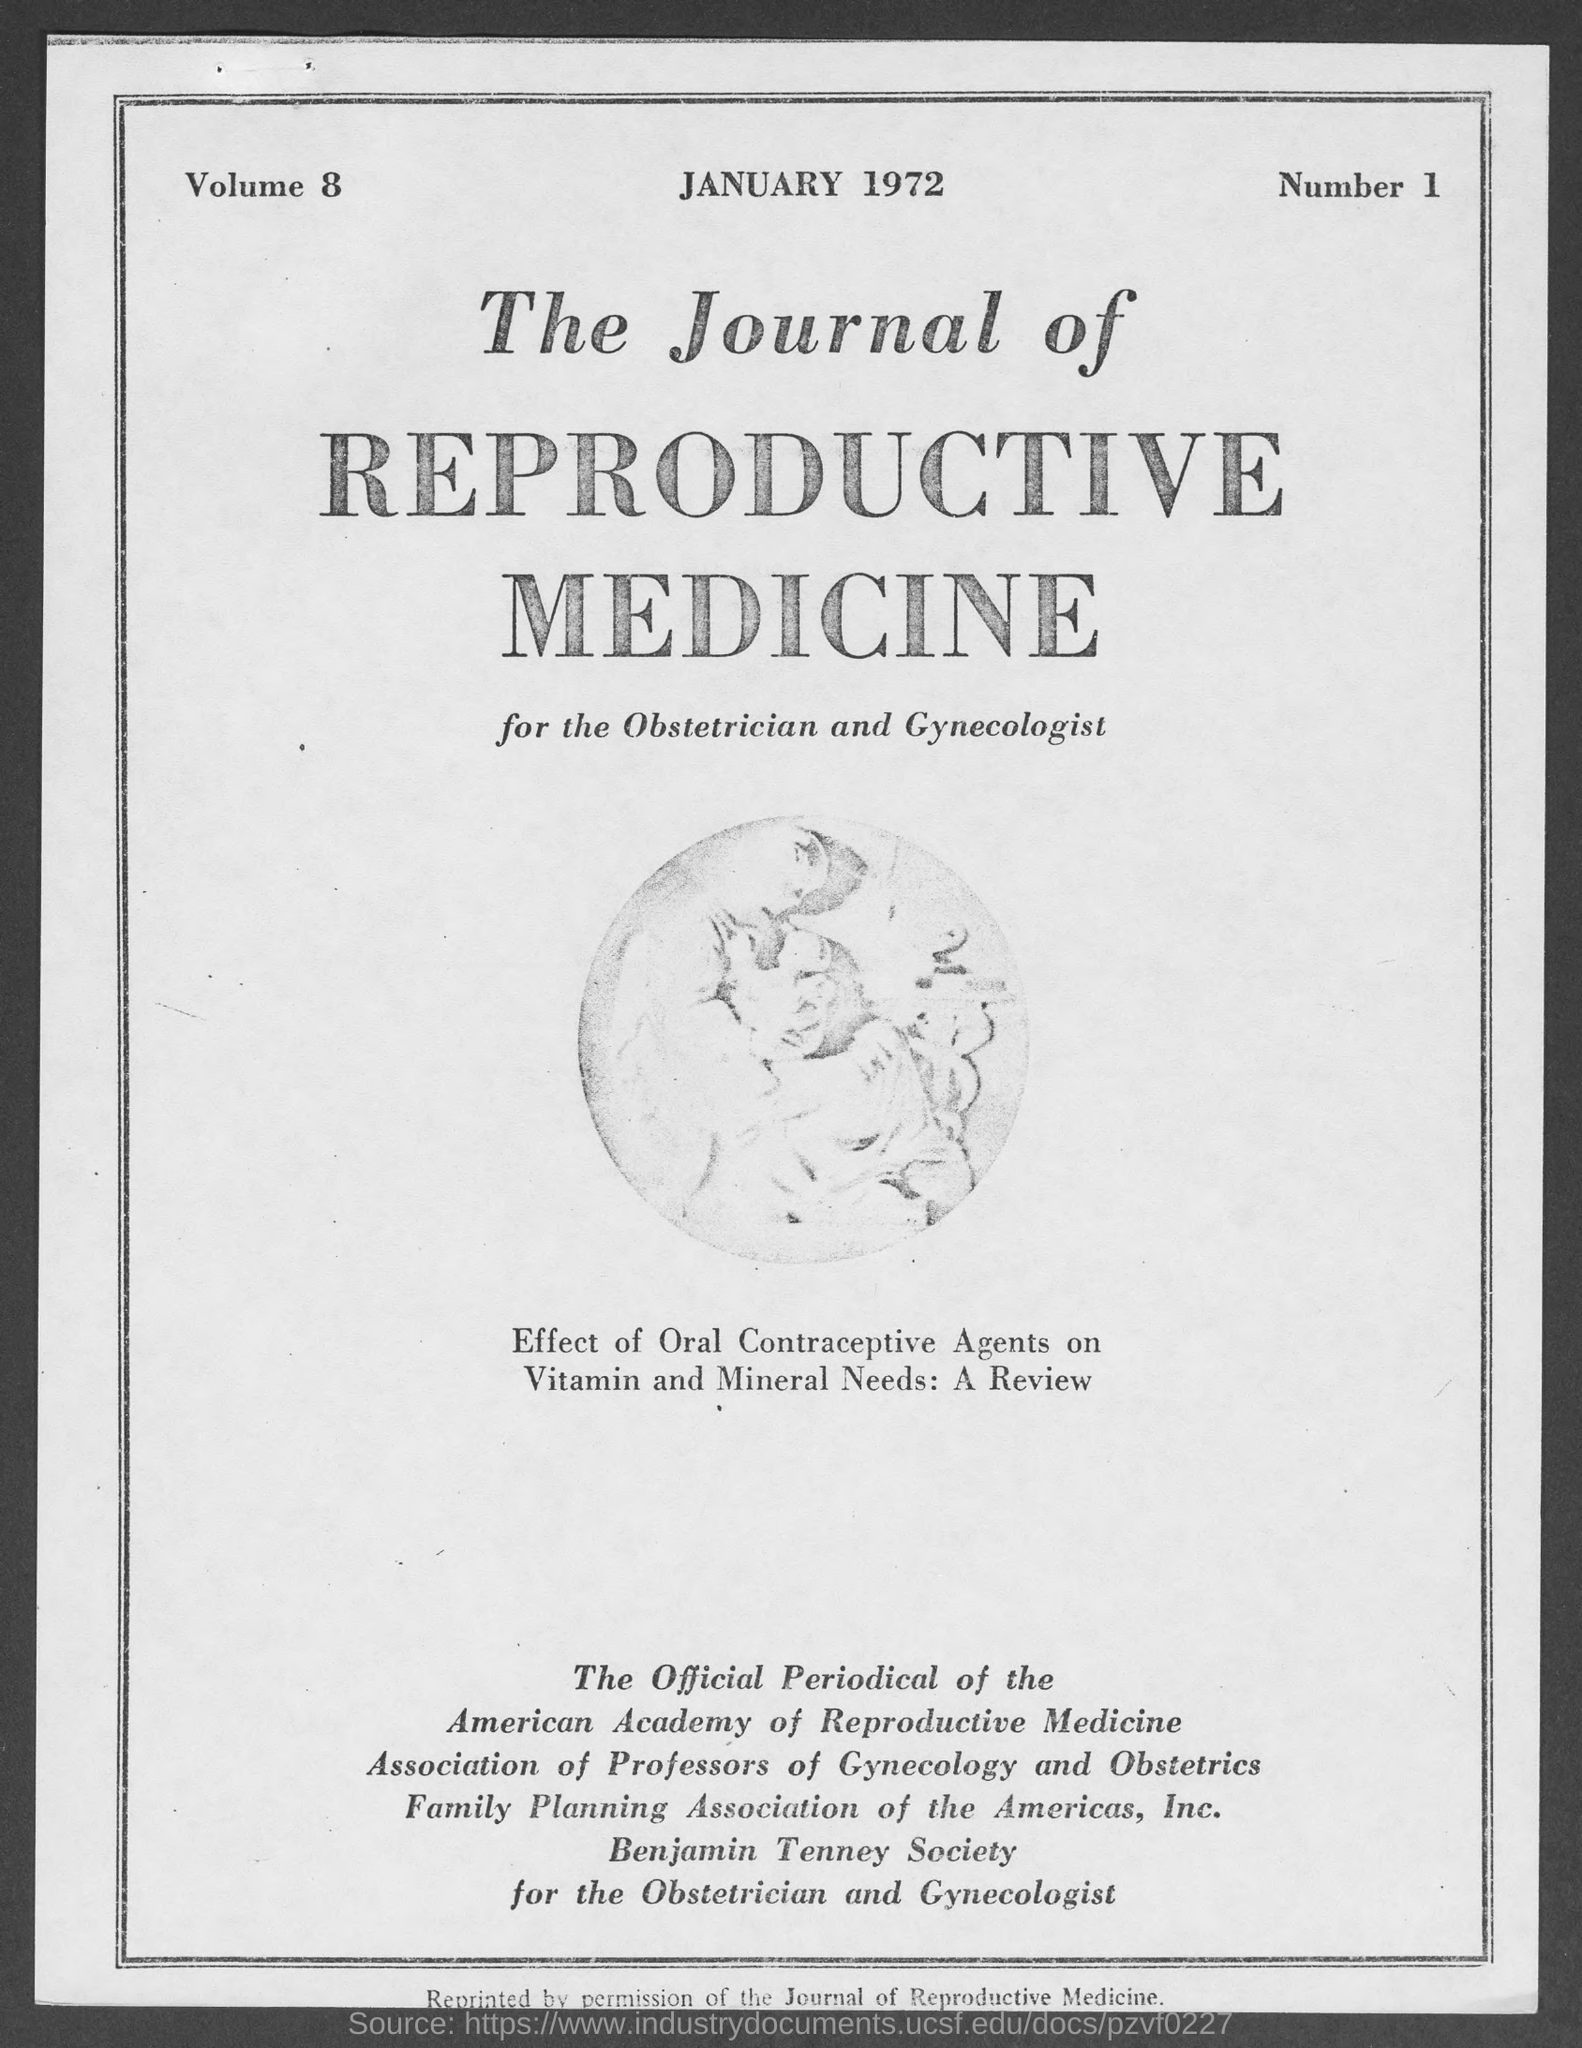What is the month and year at top of the page?
Offer a terse response. January 1972. What is the volume no.?
Give a very brief answer. 8. 